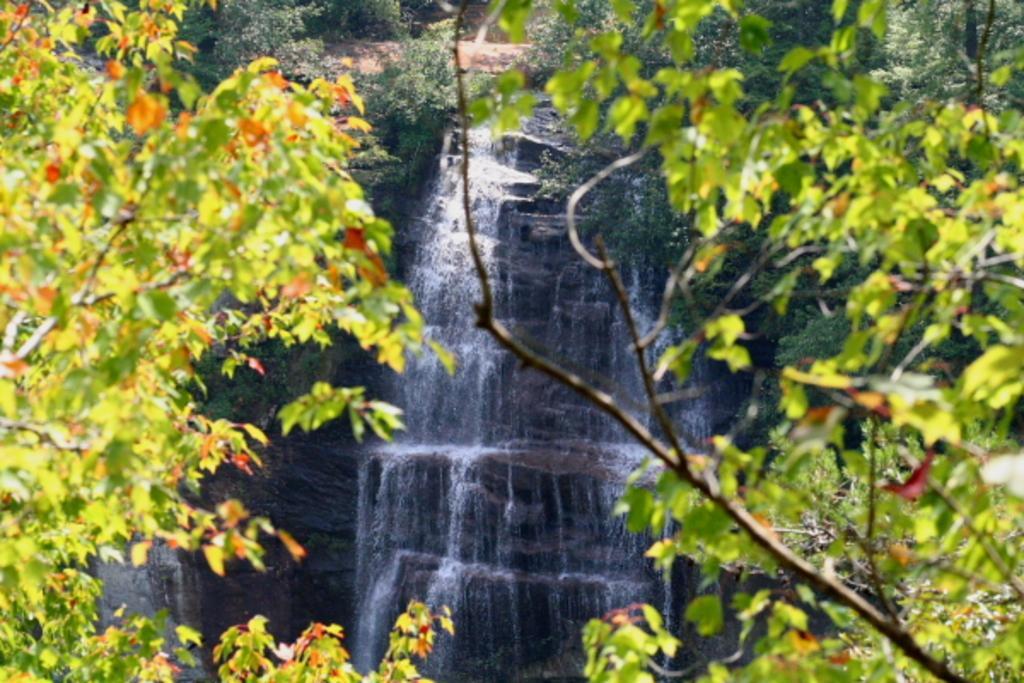Describe this image in one or two sentences. This is a picture taken in a forest. In the foreground of the picture there are trees. In the center of the picture there is a waterfall. in the background there are trees and soil. 